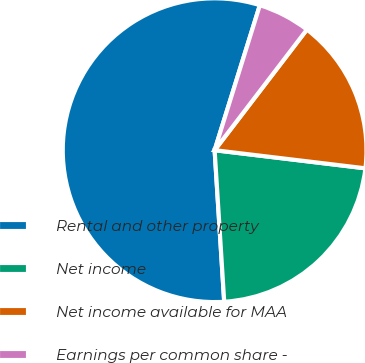<chart> <loc_0><loc_0><loc_500><loc_500><pie_chart><fcel>Rental and other property<fcel>Net income<fcel>Net income available for MAA<fcel>Earnings per common share -<nl><fcel>55.81%<fcel>22.09%<fcel>16.51%<fcel>5.58%<nl></chart> 